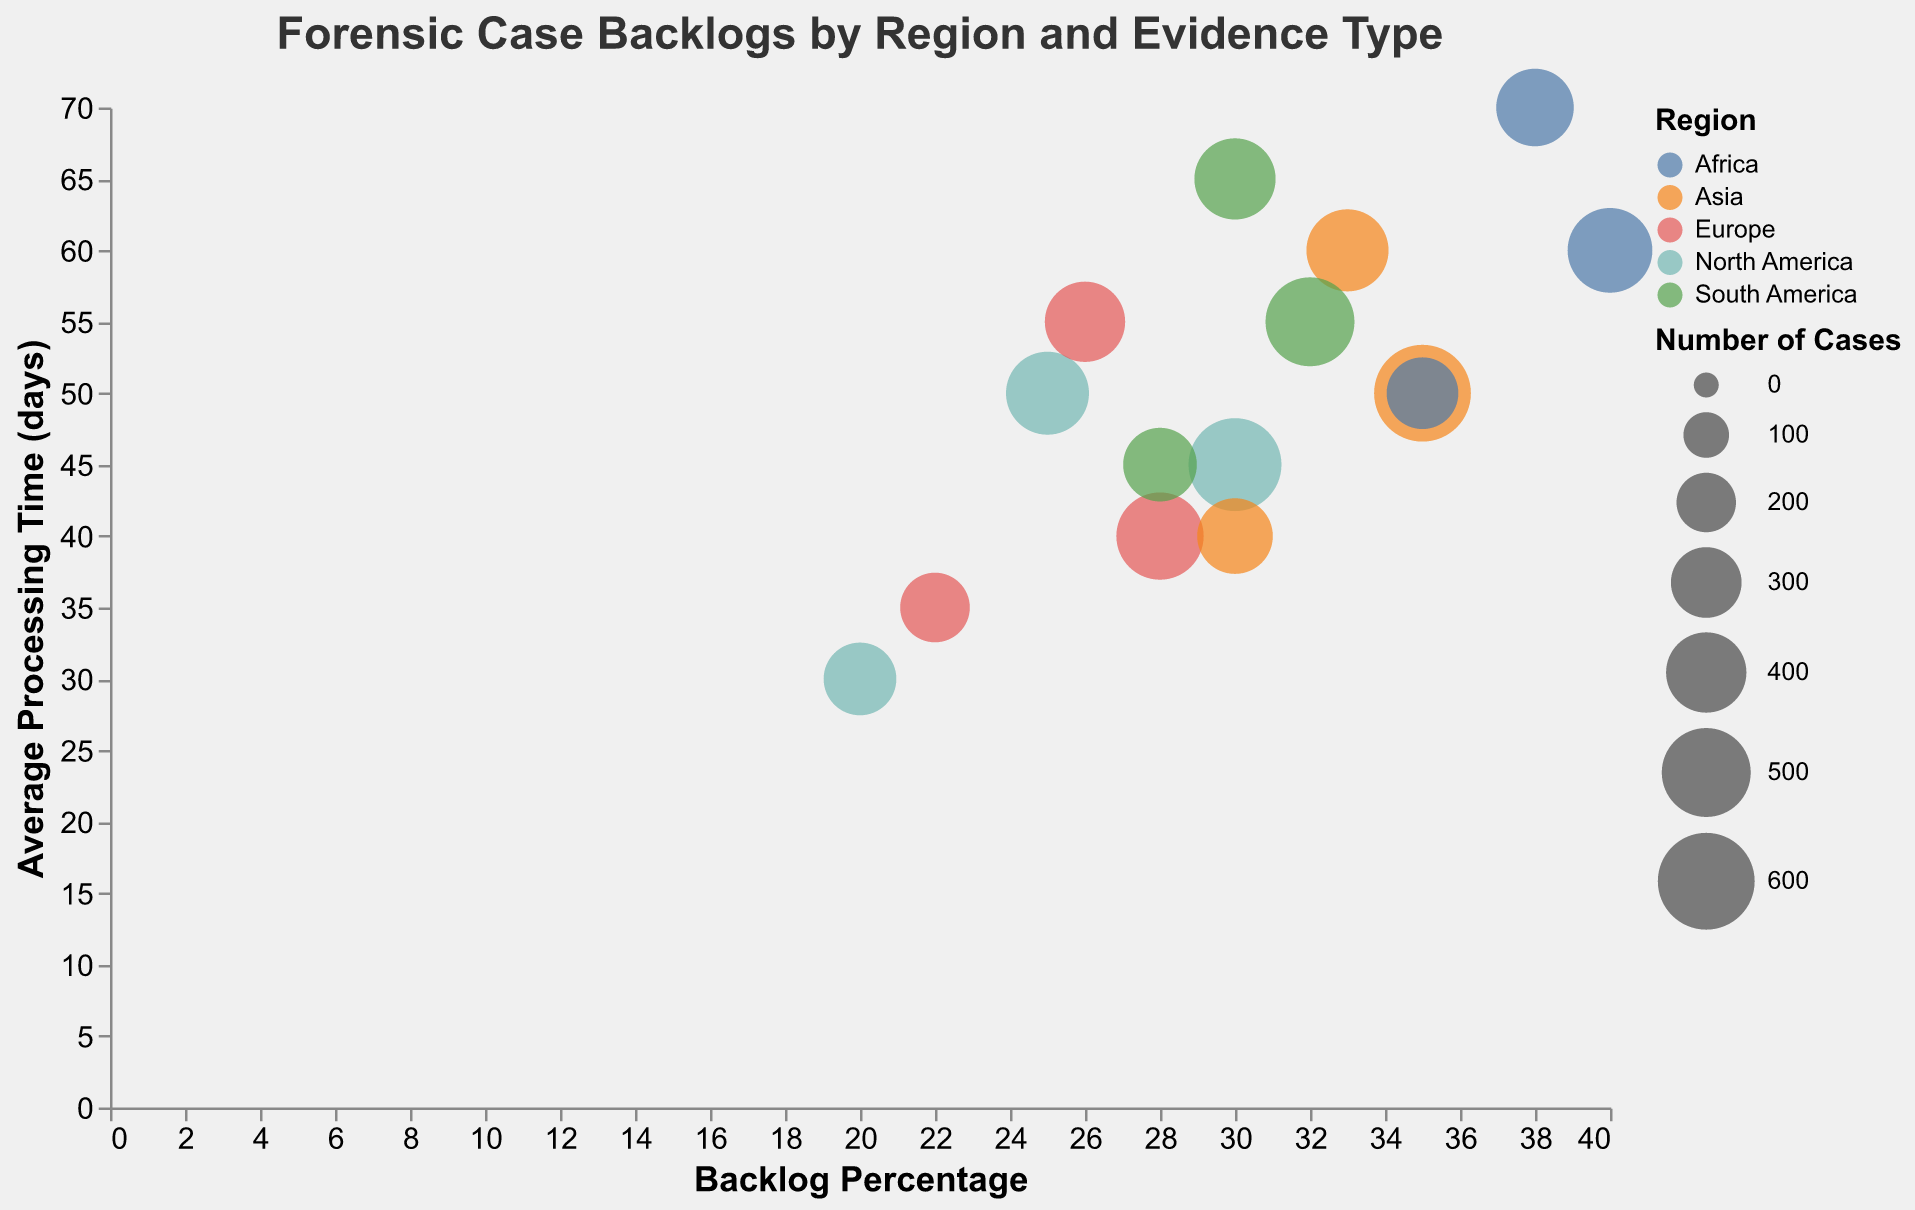What's the title of the chart? The title of the chart is visible at the top of the figure and it reads, "Forensic Case Backlogs by Region and Evidence Type."
Answer: Forensic Case Backlogs by Region and Evidence Type Which region has the highest backlog percentage for DNA evidence? By looking at the x-axis and identifying the bubbles labeled with DNA as the evidence type, we can see that Africa has the highest backlog percentage of 40%.
Answer: Africa How many cases of digital forensic evidence are reported in Asia and what is their average processing time? By locating the bubble representing Asia with digital forensic evidence on the chart, the tooltip reveals the number of cases (420) and the average processing time (60 days).
Answer: 420, 60 days Compare the backlog percentage of fingerprint evidence between North America and South America. By finding the bubbles for fingerprint evidence in North America and South America and comparing their positions along the x-axis, we see that North America's backlog percentage is 20% whereas South America's is 28%.
Answer: North America: 20%, South America: 28% Which type of forensic evidence has the shortest average processing time in Europe? By identifying the bubbles for Europe, and comparing their positions along the y-axis (average processing time), fingerprint evidence has the shortest processing time of 35 days.
Answer: Fingerprints What is the total average processing time for all types of forensic evidence in North America? Adding the average processing times for DNA (45 days), fingerprints (30 days), and digital (50 days): 45 + 30 + 50 = 125.
Answer: 125 days Which region has the largest number of forensic cases, and what type of evidence does it pertain to? By comparing the size of the bubbles, the largest bubble represents DNA evidence in Asia, with 600 cases.
Answer: Asia, DNA What is the difference in the backlog percentage between digital evidence in Asia and Africa? Comparing the x-axis positions of bubbles for digital evidence in Asia (33%) and Africa (38%), the difference is calculated as 38% - 33% = 5%.
Answer: 5% Are there more DNA cases in North America or South America? By comparing the bubble sizes labeled DNA for North America (550 cases) and South America (500 cases), North America has more cases.
Answer: North America 